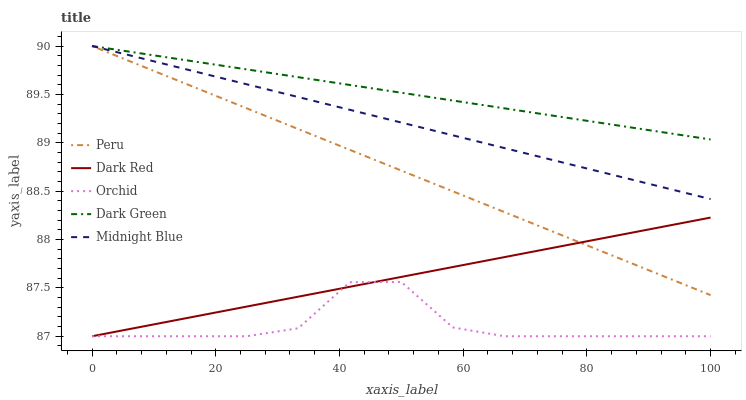Does Orchid have the minimum area under the curve?
Answer yes or no. Yes. Does Dark Green have the maximum area under the curve?
Answer yes or no. Yes. Does Midnight Blue have the minimum area under the curve?
Answer yes or no. No. Does Midnight Blue have the maximum area under the curve?
Answer yes or no. No. Is Peru the smoothest?
Answer yes or no. Yes. Is Orchid the roughest?
Answer yes or no. Yes. Is Dark Green the smoothest?
Answer yes or no. No. Is Dark Green the roughest?
Answer yes or no. No. Does Dark Red have the lowest value?
Answer yes or no. Yes. Does Midnight Blue have the lowest value?
Answer yes or no. No. Does Peru have the highest value?
Answer yes or no. Yes. Does Orchid have the highest value?
Answer yes or no. No. Is Dark Red less than Midnight Blue?
Answer yes or no. Yes. Is Midnight Blue greater than Orchid?
Answer yes or no. Yes. Does Dark Green intersect Midnight Blue?
Answer yes or no. Yes. Is Dark Green less than Midnight Blue?
Answer yes or no. No. Is Dark Green greater than Midnight Blue?
Answer yes or no. No. Does Dark Red intersect Midnight Blue?
Answer yes or no. No. 